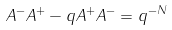Convert formula to latex. <formula><loc_0><loc_0><loc_500><loc_500>A ^ { - } A ^ { + } - q A ^ { + } A ^ { - } = q ^ { - N }</formula> 